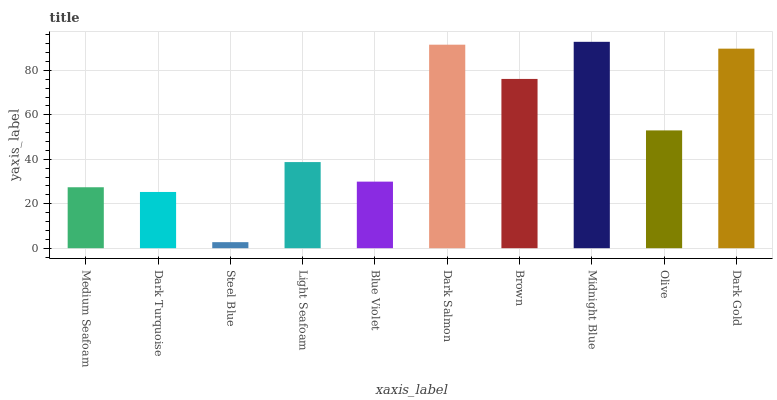Is Steel Blue the minimum?
Answer yes or no. Yes. Is Midnight Blue the maximum?
Answer yes or no. Yes. Is Dark Turquoise the minimum?
Answer yes or no. No. Is Dark Turquoise the maximum?
Answer yes or no. No. Is Medium Seafoam greater than Dark Turquoise?
Answer yes or no. Yes. Is Dark Turquoise less than Medium Seafoam?
Answer yes or no. Yes. Is Dark Turquoise greater than Medium Seafoam?
Answer yes or no. No. Is Medium Seafoam less than Dark Turquoise?
Answer yes or no. No. Is Olive the high median?
Answer yes or no. Yes. Is Light Seafoam the low median?
Answer yes or no. Yes. Is Midnight Blue the high median?
Answer yes or no. No. Is Dark Turquoise the low median?
Answer yes or no. No. 